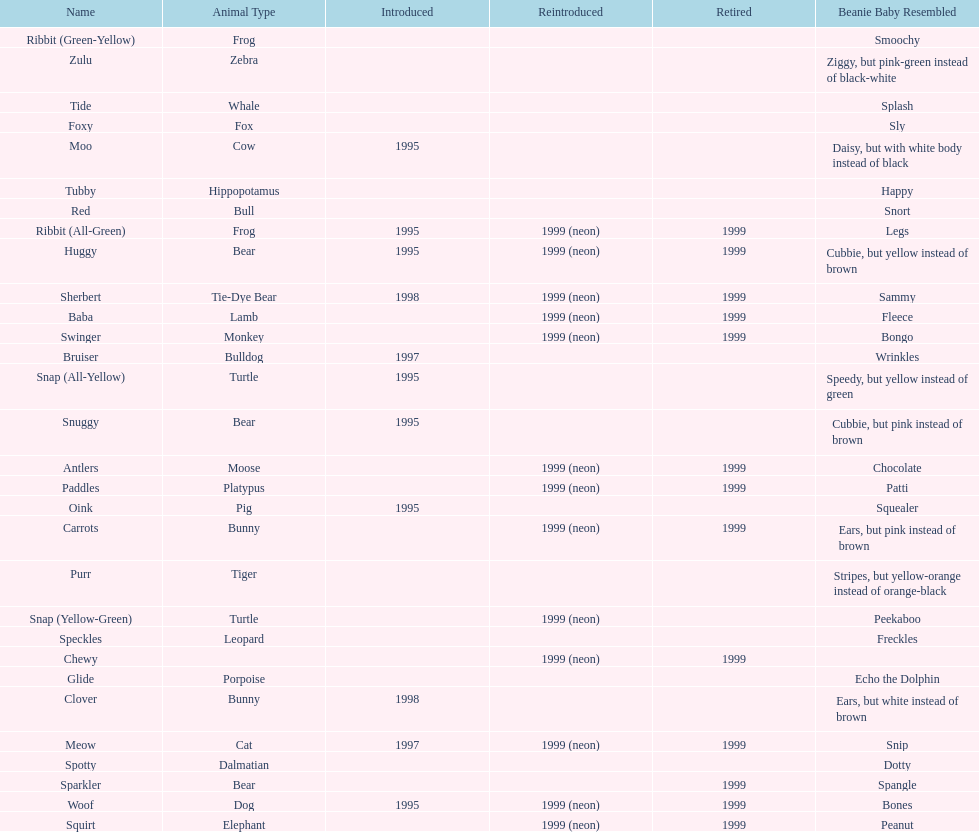Could you help me parse every detail presented in this table? {'header': ['Name', 'Animal Type', 'Introduced', 'Reintroduced', 'Retired', 'Beanie Baby Resembled'], 'rows': [['Ribbit (Green-Yellow)', 'Frog', '', '', '', 'Smoochy'], ['Zulu', 'Zebra', '', '', '', 'Ziggy, but pink-green instead of black-white'], ['Tide', 'Whale', '', '', '', 'Splash'], ['Foxy', 'Fox', '', '', '', 'Sly'], ['Moo', 'Cow', '1995', '', '', 'Daisy, but with white body instead of black'], ['Tubby', 'Hippopotamus', '', '', '', 'Happy'], ['Red', 'Bull', '', '', '', 'Snort'], ['Ribbit (All-Green)', 'Frog', '1995', '1999 (neon)', '1999', 'Legs'], ['Huggy', 'Bear', '1995', '1999 (neon)', '1999', 'Cubbie, but yellow instead of brown'], ['Sherbert', 'Tie-Dye Bear', '1998', '1999 (neon)', '1999', 'Sammy'], ['Baba', 'Lamb', '', '1999 (neon)', '1999', 'Fleece'], ['Swinger', 'Monkey', '', '1999 (neon)', '1999', 'Bongo'], ['Bruiser', 'Bulldog', '1997', '', '', 'Wrinkles'], ['Snap (All-Yellow)', 'Turtle', '1995', '', '', 'Speedy, but yellow instead of green'], ['Snuggy', 'Bear', '1995', '', '', 'Cubbie, but pink instead of brown'], ['Antlers', 'Moose', '', '1999 (neon)', '1999', 'Chocolate'], ['Paddles', 'Platypus', '', '1999 (neon)', '1999', 'Patti'], ['Oink', 'Pig', '1995', '', '', 'Squealer'], ['Carrots', 'Bunny', '', '1999 (neon)', '1999', 'Ears, but pink instead of brown'], ['Purr', 'Tiger', '', '', '', 'Stripes, but yellow-orange instead of orange-black'], ['Snap (Yellow-Green)', 'Turtle', '', '1999 (neon)', '', 'Peekaboo'], ['Speckles', 'Leopard', '', '', '', 'Freckles'], ['Chewy', '', '', '1999 (neon)', '1999', ''], ['Glide', 'Porpoise', '', '', '', 'Echo the Dolphin'], ['Clover', 'Bunny', '1998', '', '', 'Ears, but white instead of brown'], ['Meow', 'Cat', '1997', '1999 (neon)', '1999', 'Snip'], ['Spotty', 'Dalmatian', '', '', '', 'Dotty'], ['Sparkler', 'Bear', '', '', '1999', 'Spangle'], ['Woof', 'Dog', '1995', '1999 (neon)', '1999', 'Bones'], ['Squirt', 'Elephant', '', '1999 (neon)', '1999', 'Peanut']]} Name the only pillow pal that is a dalmatian. Spotty. 